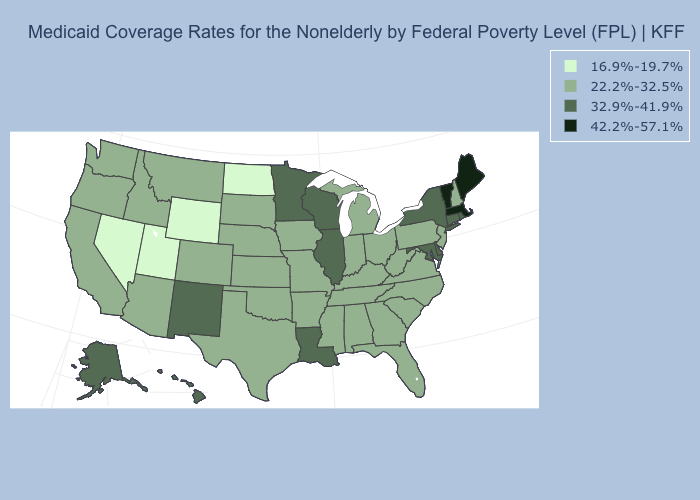What is the value of Nevada?
Be succinct. 16.9%-19.7%. What is the value of Alaska?
Write a very short answer. 32.9%-41.9%. What is the value of Washington?
Answer briefly. 22.2%-32.5%. What is the lowest value in states that border North Carolina?
Keep it brief. 22.2%-32.5%. Name the states that have a value in the range 42.2%-57.1%?
Give a very brief answer. Maine, Massachusetts, Vermont. Which states hav the highest value in the MidWest?
Quick response, please. Illinois, Minnesota, Wisconsin. Among the states that border Indiana , which have the lowest value?
Quick response, please. Kentucky, Michigan, Ohio. What is the highest value in states that border North Carolina?
Be succinct. 22.2%-32.5%. Is the legend a continuous bar?
Quick response, please. No. What is the value of Ohio?
Quick response, please. 22.2%-32.5%. Among the states that border North Dakota , which have the lowest value?
Write a very short answer. Montana, South Dakota. What is the lowest value in states that border Arkansas?
Short answer required. 22.2%-32.5%. Name the states that have a value in the range 32.9%-41.9%?
Be succinct. Alaska, Connecticut, Delaware, Hawaii, Illinois, Louisiana, Maryland, Minnesota, New Mexico, New York, Rhode Island, Wisconsin. What is the value of Washington?
Quick response, please. 22.2%-32.5%. What is the value of Louisiana?
Give a very brief answer. 32.9%-41.9%. 